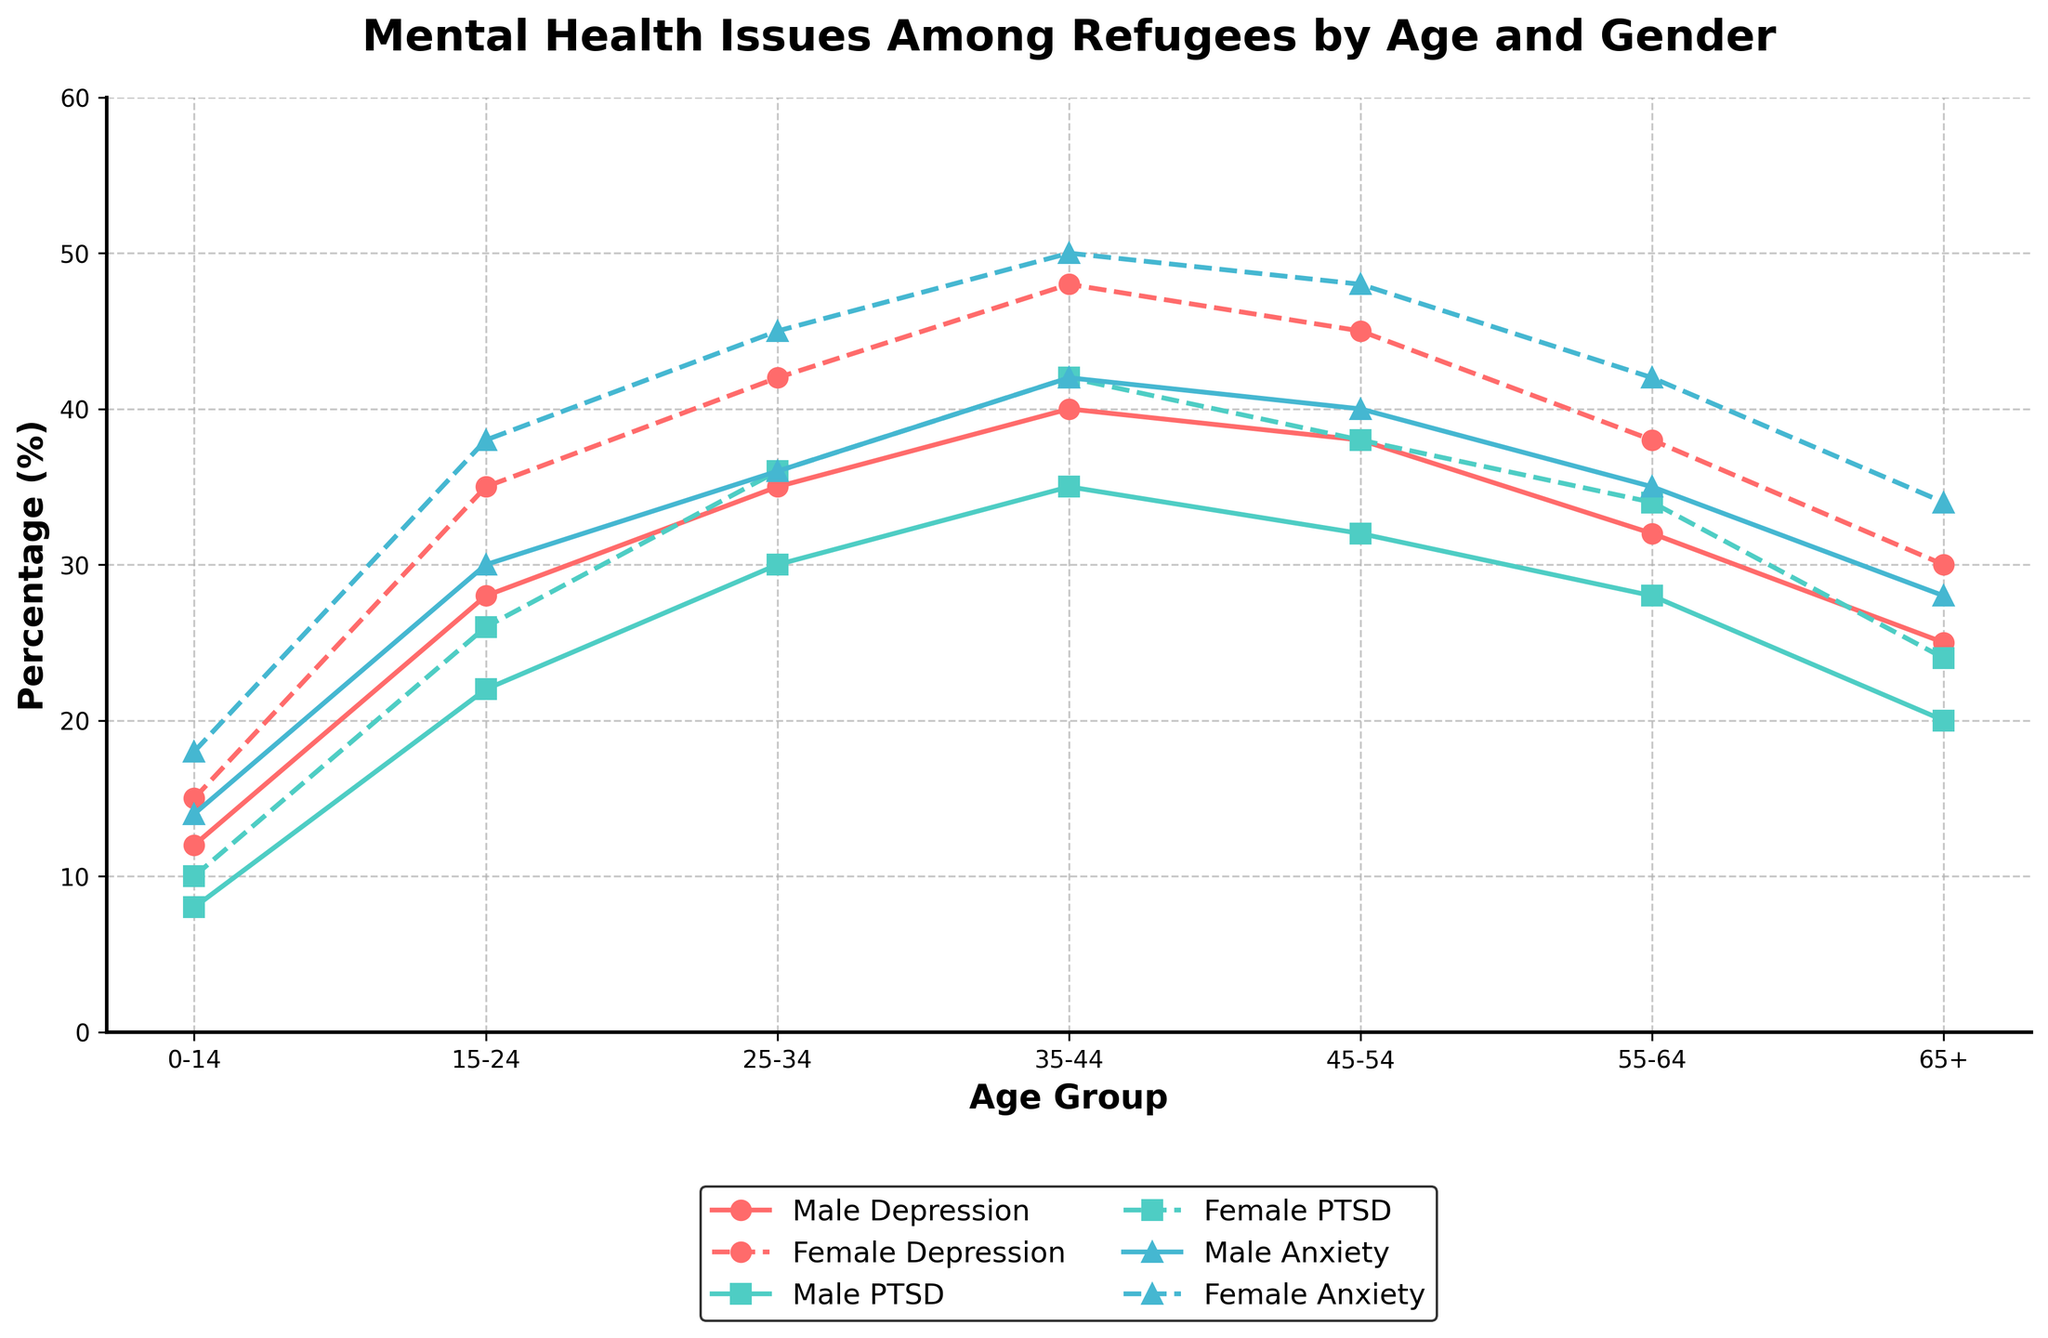What's the age group with the highest percentage of male depression? Look at the line representing male depression across age groups and identify the highest point. The highest percentage is at the age group 35-44.
Answer: 35-44 Which gender has a higher percentage of PTSD in the 25-34 age group? Compare the points for male and female PTSD in the 25-34 age group. Female PTSD is higher at 36%, while male PTSD is 30%.
Answer: Female Which age group shows the smallest difference in anxiety percentage between males and females? Calculate the difference in anxiety percentage between males and females for each age group and find the smallest difference: 0-14: 4%, 15-24: 8%, 25-34: 9%, 35-44: 8%, 45-54: 8%, 55-64: 7%, 65+: 6%. The smallest difference is in the 0-14 age group at 4%.
Answer: 0-14 What's the average percentage of PTSD for both genders in the 55-64 age group? Add the percentages of male and female PTSD for the 55-64 age group, then divide by 2. (28 + 34) / 2 = 31%.
Answer: 31% Do males or females have a higher overall trend in mental health issues across all age groups? Visually compare the lines for male and female across all categories and age groups. Generally, female percentages are higher.
Answer: Females How does female anxiety percentage change from the 45-54 age group to the 65+ age group? Look at the female anxiety percentages for the 45-54 and 65+ age groups. The percentage decreases from 48% to 34%.
Answer: Decreases What is the percentage difference between male and female depression in the 15-24 age group? Subtract the male percentage of depression from the female percentage of depression in the 15-24 age group. 35% - 28% = 7%.
Answer: 7% In which condition and age group is the gender disparity the highest? Identify the largest difference between male and female percentages for each condition and age group. The highest disparity is in anxiety for the 35-44 age group (50% - 42% = 8%).
Answer: Anxiety, 35-44 